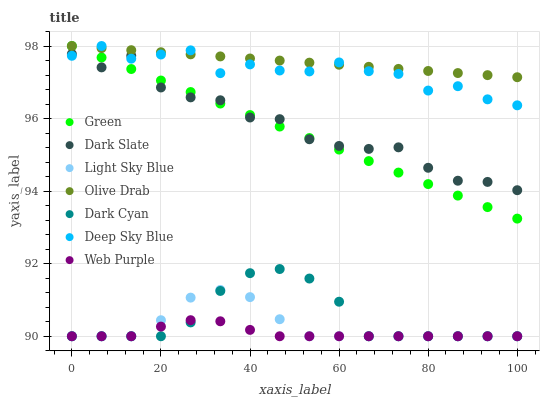Does Web Purple have the minimum area under the curve?
Answer yes or no. Yes. Does Olive Drab have the maximum area under the curve?
Answer yes or no. Yes. Does Light Sky Blue have the minimum area under the curve?
Answer yes or no. No. Does Light Sky Blue have the maximum area under the curve?
Answer yes or no. No. Is Green the smoothest?
Answer yes or no. Yes. Is Dark Slate the roughest?
Answer yes or no. Yes. Is Web Purple the smoothest?
Answer yes or no. No. Is Web Purple the roughest?
Answer yes or no. No. Does Web Purple have the lowest value?
Answer yes or no. Yes. Does Green have the lowest value?
Answer yes or no. No. Does Olive Drab have the highest value?
Answer yes or no. Yes. Does Light Sky Blue have the highest value?
Answer yes or no. No. Is Light Sky Blue less than Deep Sky Blue?
Answer yes or no. Yes. Is Green greater than Light Sky Blue?
Answer yes or no. Yes. Does Green intersect Deep Sky Blue?
Answer yes or no. Yes. Is Green less than Deep Sky Blue?
Answer yes or no. No. Is Green greater than Deep Sky Blue?
Answer yes or no. No. Does Light Sky Blue intersect Deep Sky Blue?
Answer yes or no. No. 